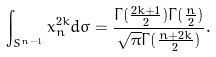Convert formula to latex. <formula><loc_0><loc_0><loc_500><loc_500>\int _ { S ^ { n - 1 } } x _ { n } ^ { 2 k } d \sigma = \frac { \Gamma ( \frac { 2 k + 1 } { 2 } ) \Gamma ( \frac { n } { 2 } ) } { \sqrt { \pi } \Gamma ( \frac { n + 2 k } { 2 } ) } .</formula> 